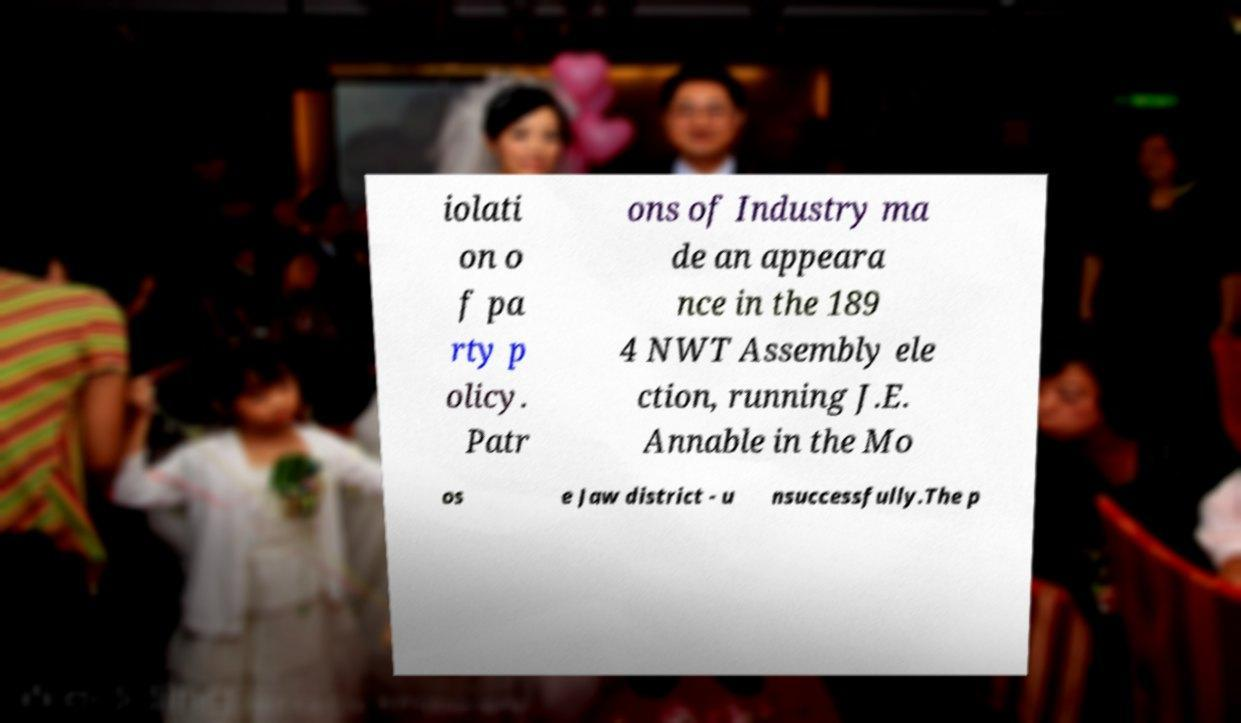For documentation purposes, I need the text within this image transcribed. Could you provide that? iolati on o f pa rty p olicy. Patr ons of Industry ma de an appeara nce in the 189 4 NWT Assembly ele ction, running J.E. Annable in the Mo os e Jaw district - u nsuccessfully.The p 